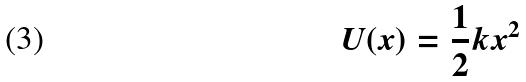<formula> <loc_0><loc_0><loc_500><loc_500>U ( x ) = \frac { 1 } { 2 } k x ^ { 2 }</formula> 